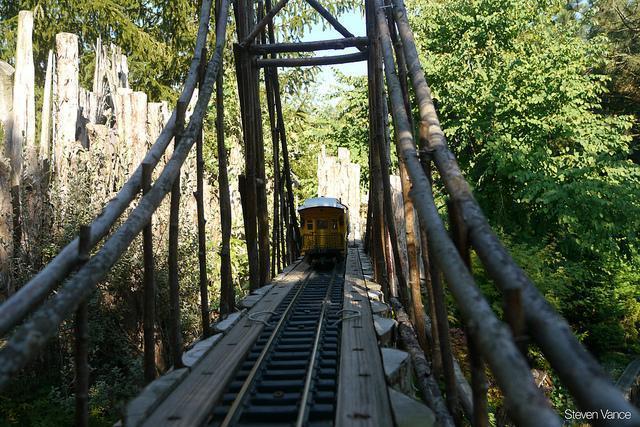How many people have umbrellas?
Give a very brief answer. 0. 